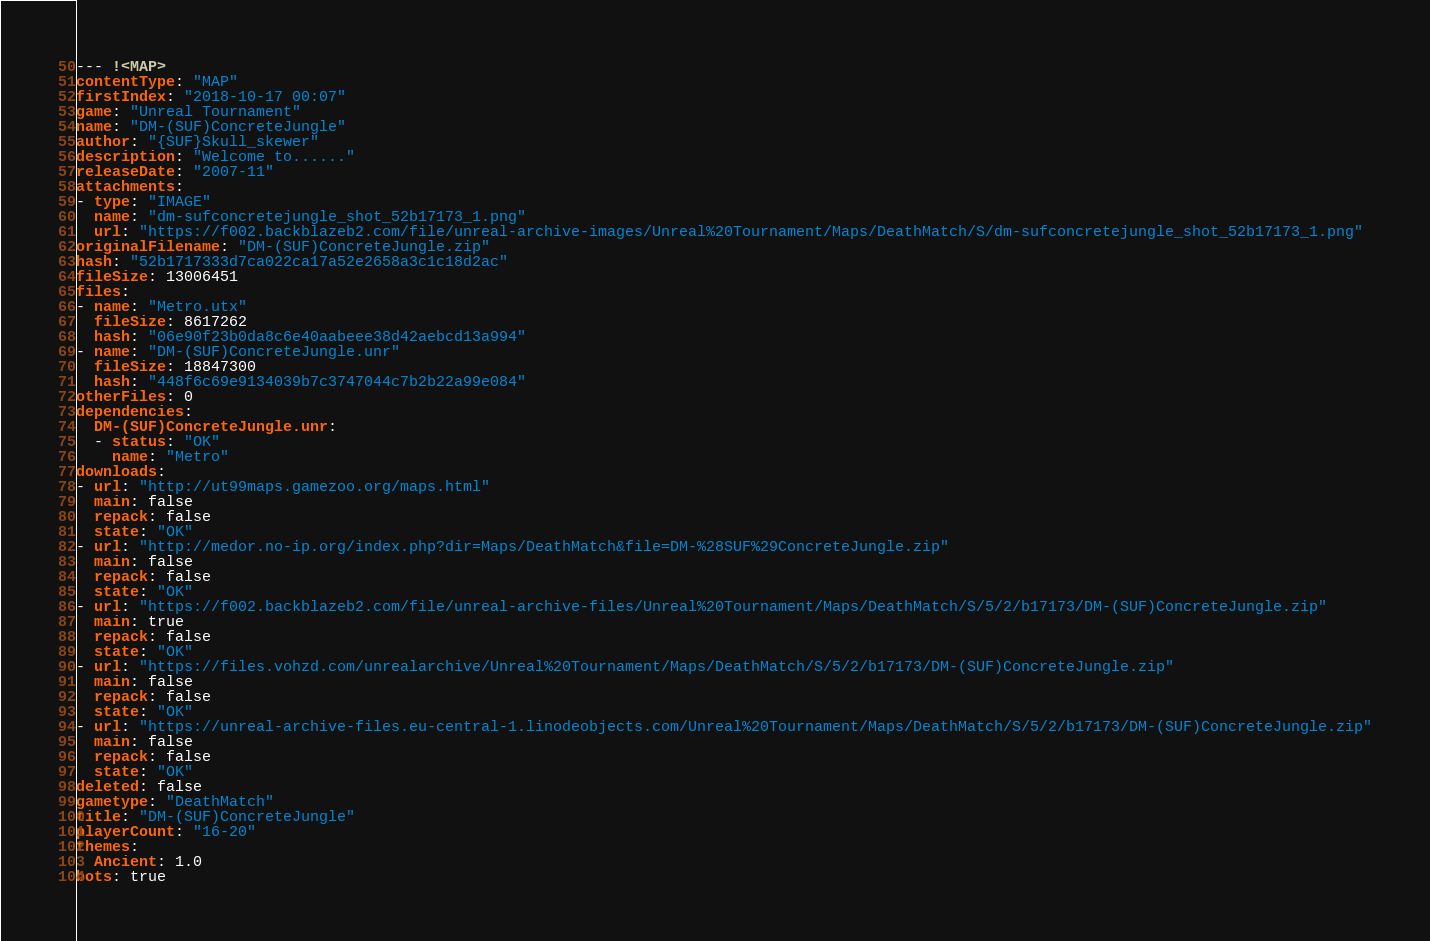<code> <loc_0><loc_0><loc_500><loc_500><_YAML_>--- !<MAP>
contentType: "MAP"
firstIndex: "2018-10-17 00:07"
game: "Unreal Tournament"
name: "DM-(SUF)ConcreteJungle"
author: "{SUF}Skull_skewer"
description: "Welcome to......"
releaseDate: "2007-11"
attachments:
- type: "IMAGE"
  name: "dm-sufconcretejungle_shot_52b17173_1.png"
  url: "https://f002.backblazeb2.com/file/unreal-archive-images/Unreal%20Tournament/Maps/DeathMatch/S/dm-sufconcretejungle_shot_52b17173_1.png"
originalFilename: "DM-(SUF)ConcreteJungle.zip"
hash: "52b1717333d7ca022ca17a52e2658a3c1c18d2ac"
fileSize: 13006451
files:
- name: "Metro.utx"
  fileSize: 8617262
  hash: "06e90f23b0da8c6e40aabeee38d42aebcd13a994"
- name: "DM-(SUF)ConcreteJungle.unr"
  fileSize: 18847300
  hash: "448f6c69e9134039b7c3747044c7b2b22a99e084"
otherFiles: 0
dependencies:
  DM-(SUF)ConcreteJungle.unr:
  - status: "OK"
    name: "Metro"
downloads:
- url: "http://ut99maps.gamezoo.org/maps.html"
  main: false
  repack: false
  state: "OK"
- url: "http://medor.no-ip.org/index.php?dir=Maps/DeathMatch&file=DM-%28SUF%29ConcreteJungle.zip"
  main: false
  repack: false
  state: "OK"
- url: "https://f002.backblazeb2.com/file/unreal-archive-files/Unreal%20Tournament/Maps/DeathMatch/S/5/2/b17173/DM-(SUF)ConcreteJungle.zip"
  main: true
  repack: false
  state: "OK"
- url: "https://files.vohzd.com/unrealarchive/Unreal%20Tournament/Maps/DeathMatch/S/5/2/b17173/DM-(SUF)ConcreteJungle.zip"
  main: false
  repack: false
  state: "OK"
- url: "https://unreal-archive-files.eu-central-1.linodeobjects.com/Unreal%20Tournament/Maps/DeathMatch/S/5/2/b17173/DM-(SUF)ConcreteJungle.zip"
  main: false
  repack: false
  state: "OK"
deleted: false
gametype: "DeathMatch"
title: "DM-(SUF)ConcreteJungle"
playerCount: "16-20"
themes:
  Ancient: 1.0
bots: true
</code> 